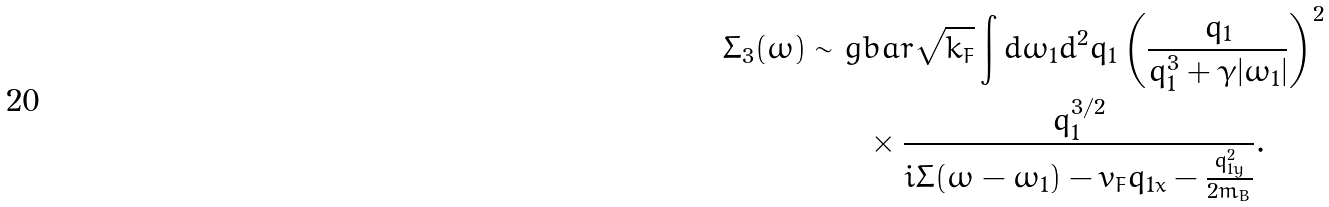<formula> <loc_0><loc_0><loc_500><loc_500>\Sigma _ { 3 } ( \omega ) \sim & \ g b a r \sqrt { k _ { F } } \int d \omega _ { 1 } d ^ { 2 } q _ { 1 } \left ( \frac { q _ { 1 } } { q _ { 1 } ^ { 3 } + \gamma | \omega _ { 1 } | } \right ) ^ { 2 } \\ & \quad \times \frac { q _ { 1 } ^ { 3 / 2 } } { i \Sigma ( \omega - \omega _ { 1 } ) - v _ { F } q _ { 1 x } - \frac { q _ { 1 y } ^ { 2 } } { 2 m _ { B } } } .</formula> 